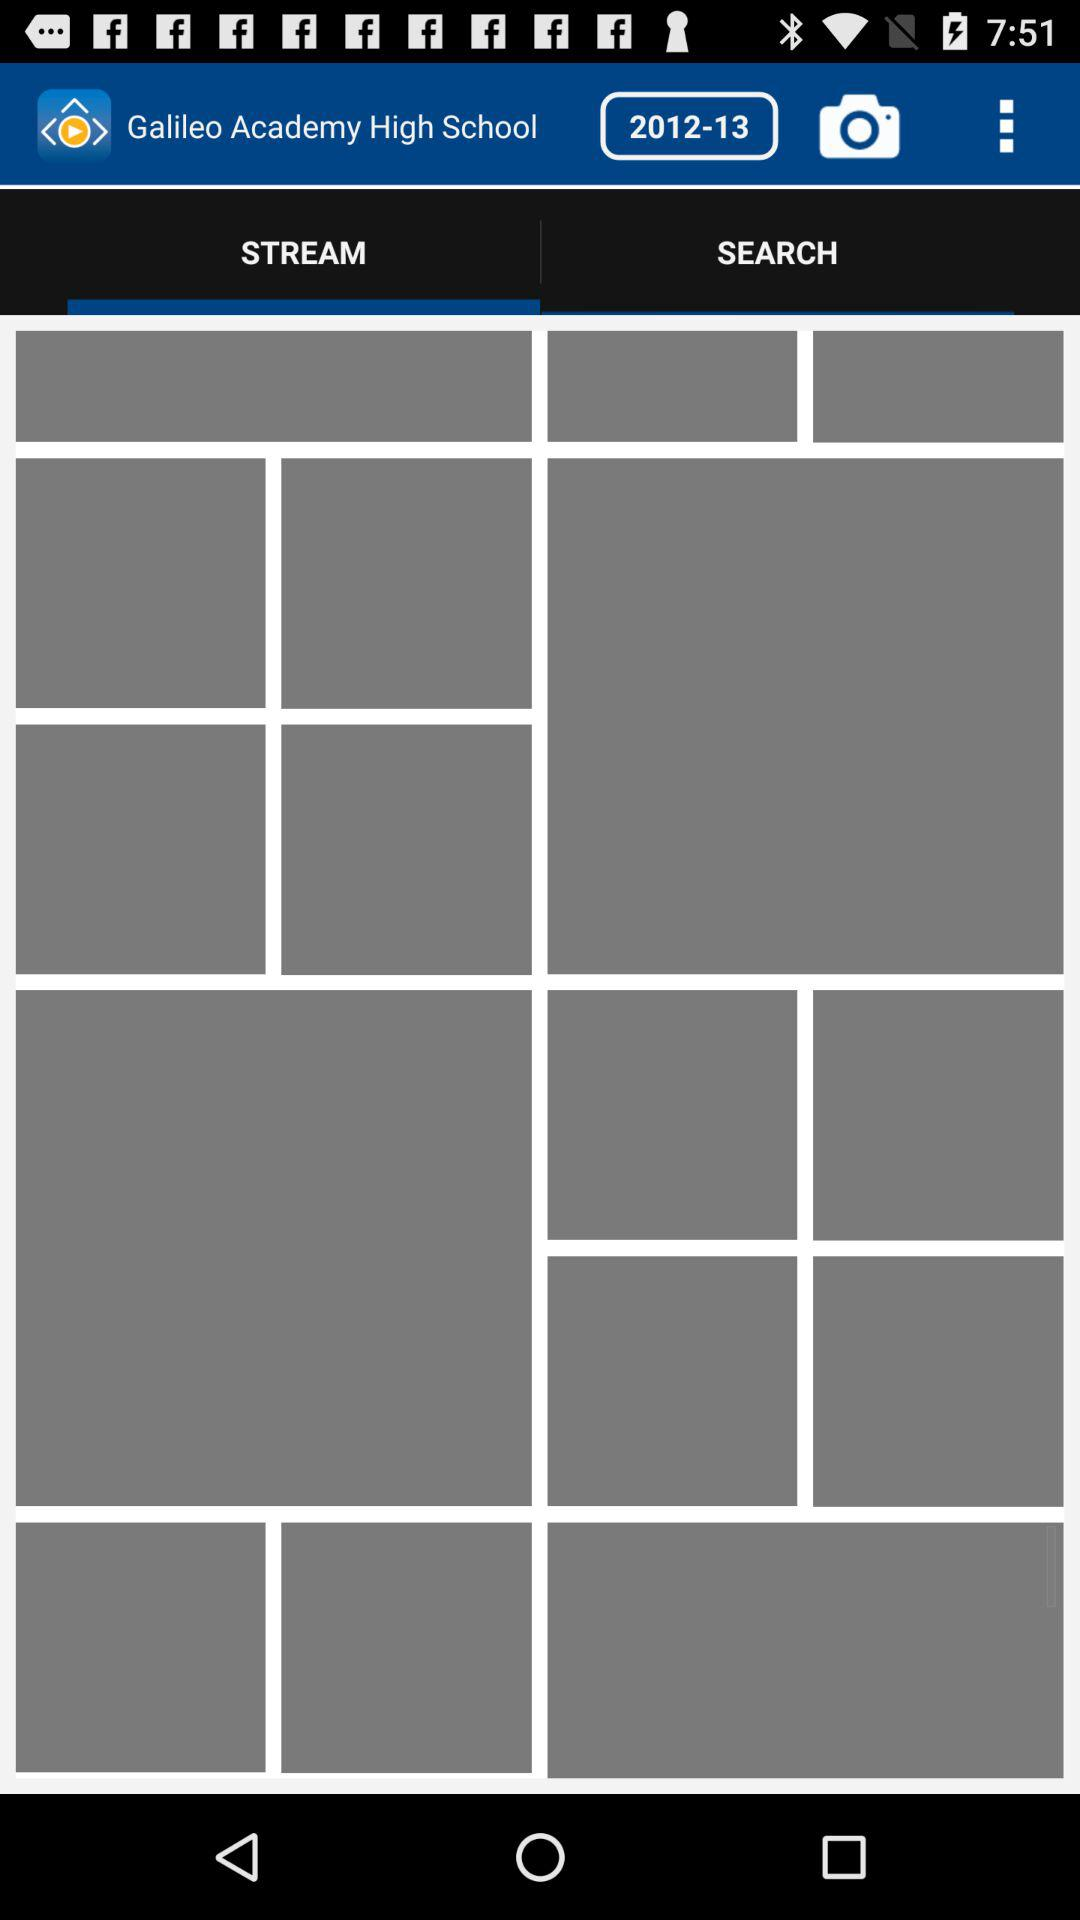How many items are in "SEARCH"?
When the provided information is insufficient, respond with <no answer>. <no answer> 